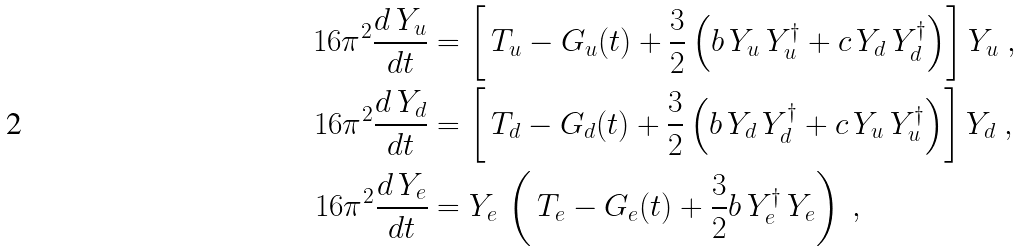<formula> <loc_0><loc_0><loc_500><loc_500>1 6 \pi ^ { 2 } \frac { d \, Y _ { u } } { d t } & = \left [ \, T _ { u } - G _ { u } ( t ) + \frac { 3 } { 2 } \left ( b \, Y _ { u } \, Y _ { u } ^ { \dagger } + c \, Y _ { d } \, Y _ { d } ^ { \dagger } \right ) \right ] Y _ { u } \ , \\ 1 6 \pi ^ { 2 } \frac { d \, Y _ { d } } { d t } & = \left [ \, T _ { d } - G _ { d } ( t ) + \frac { 3 } { 2 } \left ( b \, Y _ { d } \, Y _ { d } ^ { \dagger } + c \, Y _ { u } \, Y _ { u } ^ { \dagger } \right ) \right ] Y _ { d } \ , \\ 1 6 \pi ^ { 2 } \frac { d \, Y _ { e } } { d t } & = Y _ { e } \, \left ( \, T _ { e } - G _ { e } ( t ) + \frac { 3 } { 2 } b \, Y _ { e } ^ { \dagger } \, Y _ { e } \right ) \ ,</formula> 